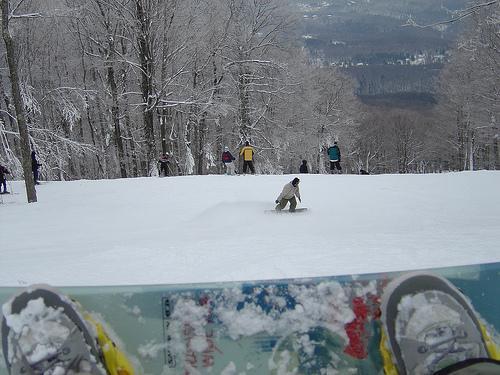How many people are seen in this photo?
Give a very brief answer. 5. 